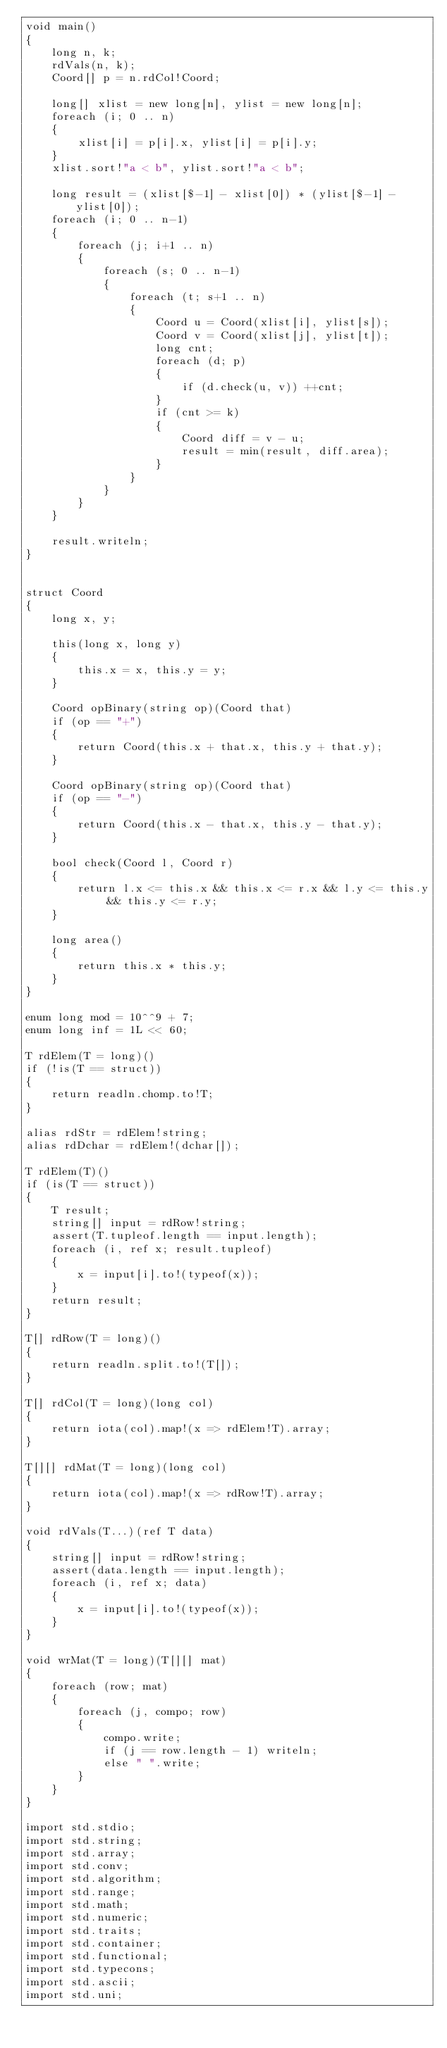<code> <loc_0><loc_0><loc_500><loc_500><_D_>void main()
{
    long n, k;
    rdVals(n, k);
    Coord[] p = n.rdCol!Coord;

    long[] xlist = new long[n], ylist = new long[n];
    foreach (i; 0 .. n)
    {
        xlist[i] = p[i].x, ylist[i] = p[i].y;
    }
    xlist.sort!"a < b", ylist.sort!"a < b";

    long result = (xlist[$-1] - xlist[0]) * (ylist[$-1] - ylist[0]);
    foreach (i; 0 .. n-1)
    {
        foreach (j; i+1 .. n)
        {
            foreach (s; 0 .. n-1)
            {
                foreach (t; s+1 .. n)
                {
                    Coord u = Coord(xlist[i], ylist[s]);
                    Coord v = Coord(xlist[j], ylist[t]);
                    long cnt;
                    foreach (d; p)
                    {
                        if (d.check(u, v)) ++cnt;
                    }
                    if (cnt >= k)
                    {
                        Coord diff = v - u;
                        result = min(result, diff.area);
                    }
                }
            }
        }
    }

    result.writeln;
}


struct Coord
{
    long x, y;

    this(long x, long y)
    {
        this.x = x, this.y = y;
    }

    Coord opBinary(string op)(Coord that)
    if (op == "+")
    {
        return Coord(this.x + that.x, this.y + that.y);
    }

    Coord opBinary(string op)(Coord that)
    if (op == "-")
    {
        return Coord(this.x - that.x, this.y - that.y);
    }

    bool check(Coord l, Coord r)
    {
        return l.x <= this.x && this.x <= r.x && l.y <= this.y && this.y <= r.y;
    }

    long area()
    {
        return this.x * this.y;
    }
}

enum long mod = 10^^9 + 7;
enum long inf = 1L << 60;

T rdElem(T = long)()
if (!is(T == struct))
{
    return readln.chomp.to!T;
}

alias rdStr = rdElem!string;
alias rdDchar = rdElem!(dchar[]);

T rdElem(T)()
if (is(T == struct))
{
    T result;
    string[] input = rdRow!string;
    assert(T.tupleof.length == input.length);
    foreach (i, ref x; result.tupleof)
    {
        x = input[i].to!(typeof(x));
    }
    return result;
}

T[] rdRow(T = long)()
{
    return readln.split.to!(T[]);
}

T[] rdCol(T = long)(long col)
{
    return iota(col).map!(x => rdElem!T).array;
}

T[][] rdMat(T = long)(long col)
{
    return iota(col).map!(x => rdRow!T).array;
}

void rdVals(T...)(ref T data)
{
    string[] input = rdRow!string;
    assert(data.length == input.length);
    foreach (i, ref x; data)
    {
        x = input[i].to!(typeof(x));
    }
}

void wrMat(T = long)(T[][] mat)
{
    foreach (row; mat)
    {
        foreach (j, compo; row)
        {
            compo.write;
            if (j == row.length - 1) writeln;
            else " ".write;
        }
    }
}

import std.stdio;
import std.string;
import std.array;
import std.conv;
import std.algorithm;
import std.range;
import std.math;
import std.numeric;
import std.traits;
import std.container;
import std.functional;
import std.typecons;
import std.ascii;
import std.uni;</code> 